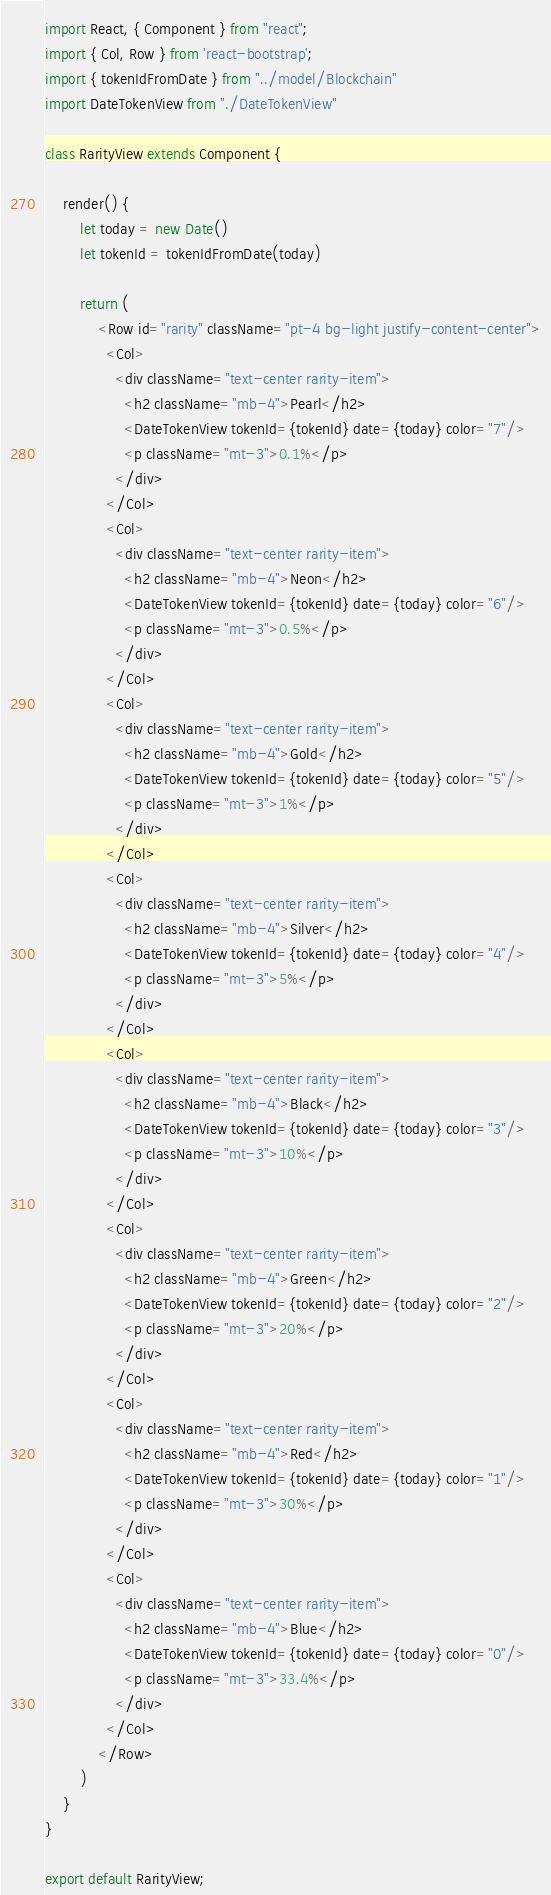Convert code to text. <code><loc_0><loc_0><loc_500><loc_500><_JavaScript_>import React, { Component } from "react";
import { Col, Row } from 'react-bootstrap';
import { tokenIdFromDate } from "../model/Blockchain"
import DateTokenView from "./DateTokenView"

class RarityView extends Component {

    render() {
        let today = new Date()
        let tokenId = tokenIdFromDate(today)

        return (
            <Row id="rarity" className="pt-4 bg-light justify-content-center">
              <Col>
                <div className="text-center rarity-item">
                  <h2 className="mb-4">Pearl</h2>
                  <DateTokenView tokenId={tokenId} date={today} color="7"/>
                  <p className="mt-3">0.1%</p>
                </div>
              </Col>
              <Col>
                <div className="text-center rarity-item">
                  <h2 className="mb-4">Neon</h2>
                  <DateTokenView tokenId={tokenId} date={today} color="6"/>
                  <p className="mt-3">0.5%</p>
                </div>
              </Col>
              <Col>
                <div className="text-center rarity-item">
                  <h2 className="mb-4">Gold</h2>
                  <DateTokenView tokenId={tokenId} date={today} color="5"/>
                  <p className="mt-3">1%</p>
                </div>
              </Col>
              <Col>
                <div className="text-center rarity-item">
                  <h2 className="mb-4">Silver</h2>
                  <DateTokenView tokenId={tokenId} date={today} color="4"/>
                  <p className="mt-3">5%</p>
                </div>
              </Col>
              <Col>
                <div className="text-center rarity-item">
                  <h2 className="mb-4">Black</h2>
                  <DateTokenView tokenId={tokenId} date={today} color="3"/>
                  <p className="mt-3">10%</p>
                </div>
              </Col>
              <Col>
                <div className="text-center rarity-item">
                  <h2 className="mb-4">Green</h2>
                  <DateTokenView tokenId={tokenId} date={today} color="2"/>
                  <p className="mt-3">20%</p>
                </div>
              </Col>
              <Col>
                <div className="text-center rarity-item">
                  <h2 className="mb-4">Red</h2>
                  <DateTokenView tokenId={tokenId} date={today} color="1"/>
                  <p className="mt-3">30%</p>
                </div>
              </Col>
              <Col>
                <div className="text-center rarity-item">
                  <h2 className="mb-4">Blue</h2>
                  <DateTokenView tokenId={tokenId} date={today} color="0"/>
                  <p className="mt-3">33.4%</p>
                </div>
              </Col>
            </Row>
        )
    }
}

export default RarityView;</code> 